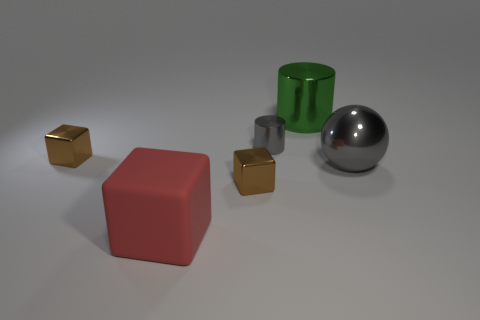Add 1 big red blocks. How many objects exist? 7 Subtract all balls. How many objects are left? 5 Subtract 0 yellow cylinders. How many objects are left? 6 Subtract all gray metallic spheres. Subtract all green cylinders. How many objects are left? 4 Add 6 big things. How many big things are left? 9 Add 5 large yellow rubber blocks. How many large yellow rubber blocks exist? 5 